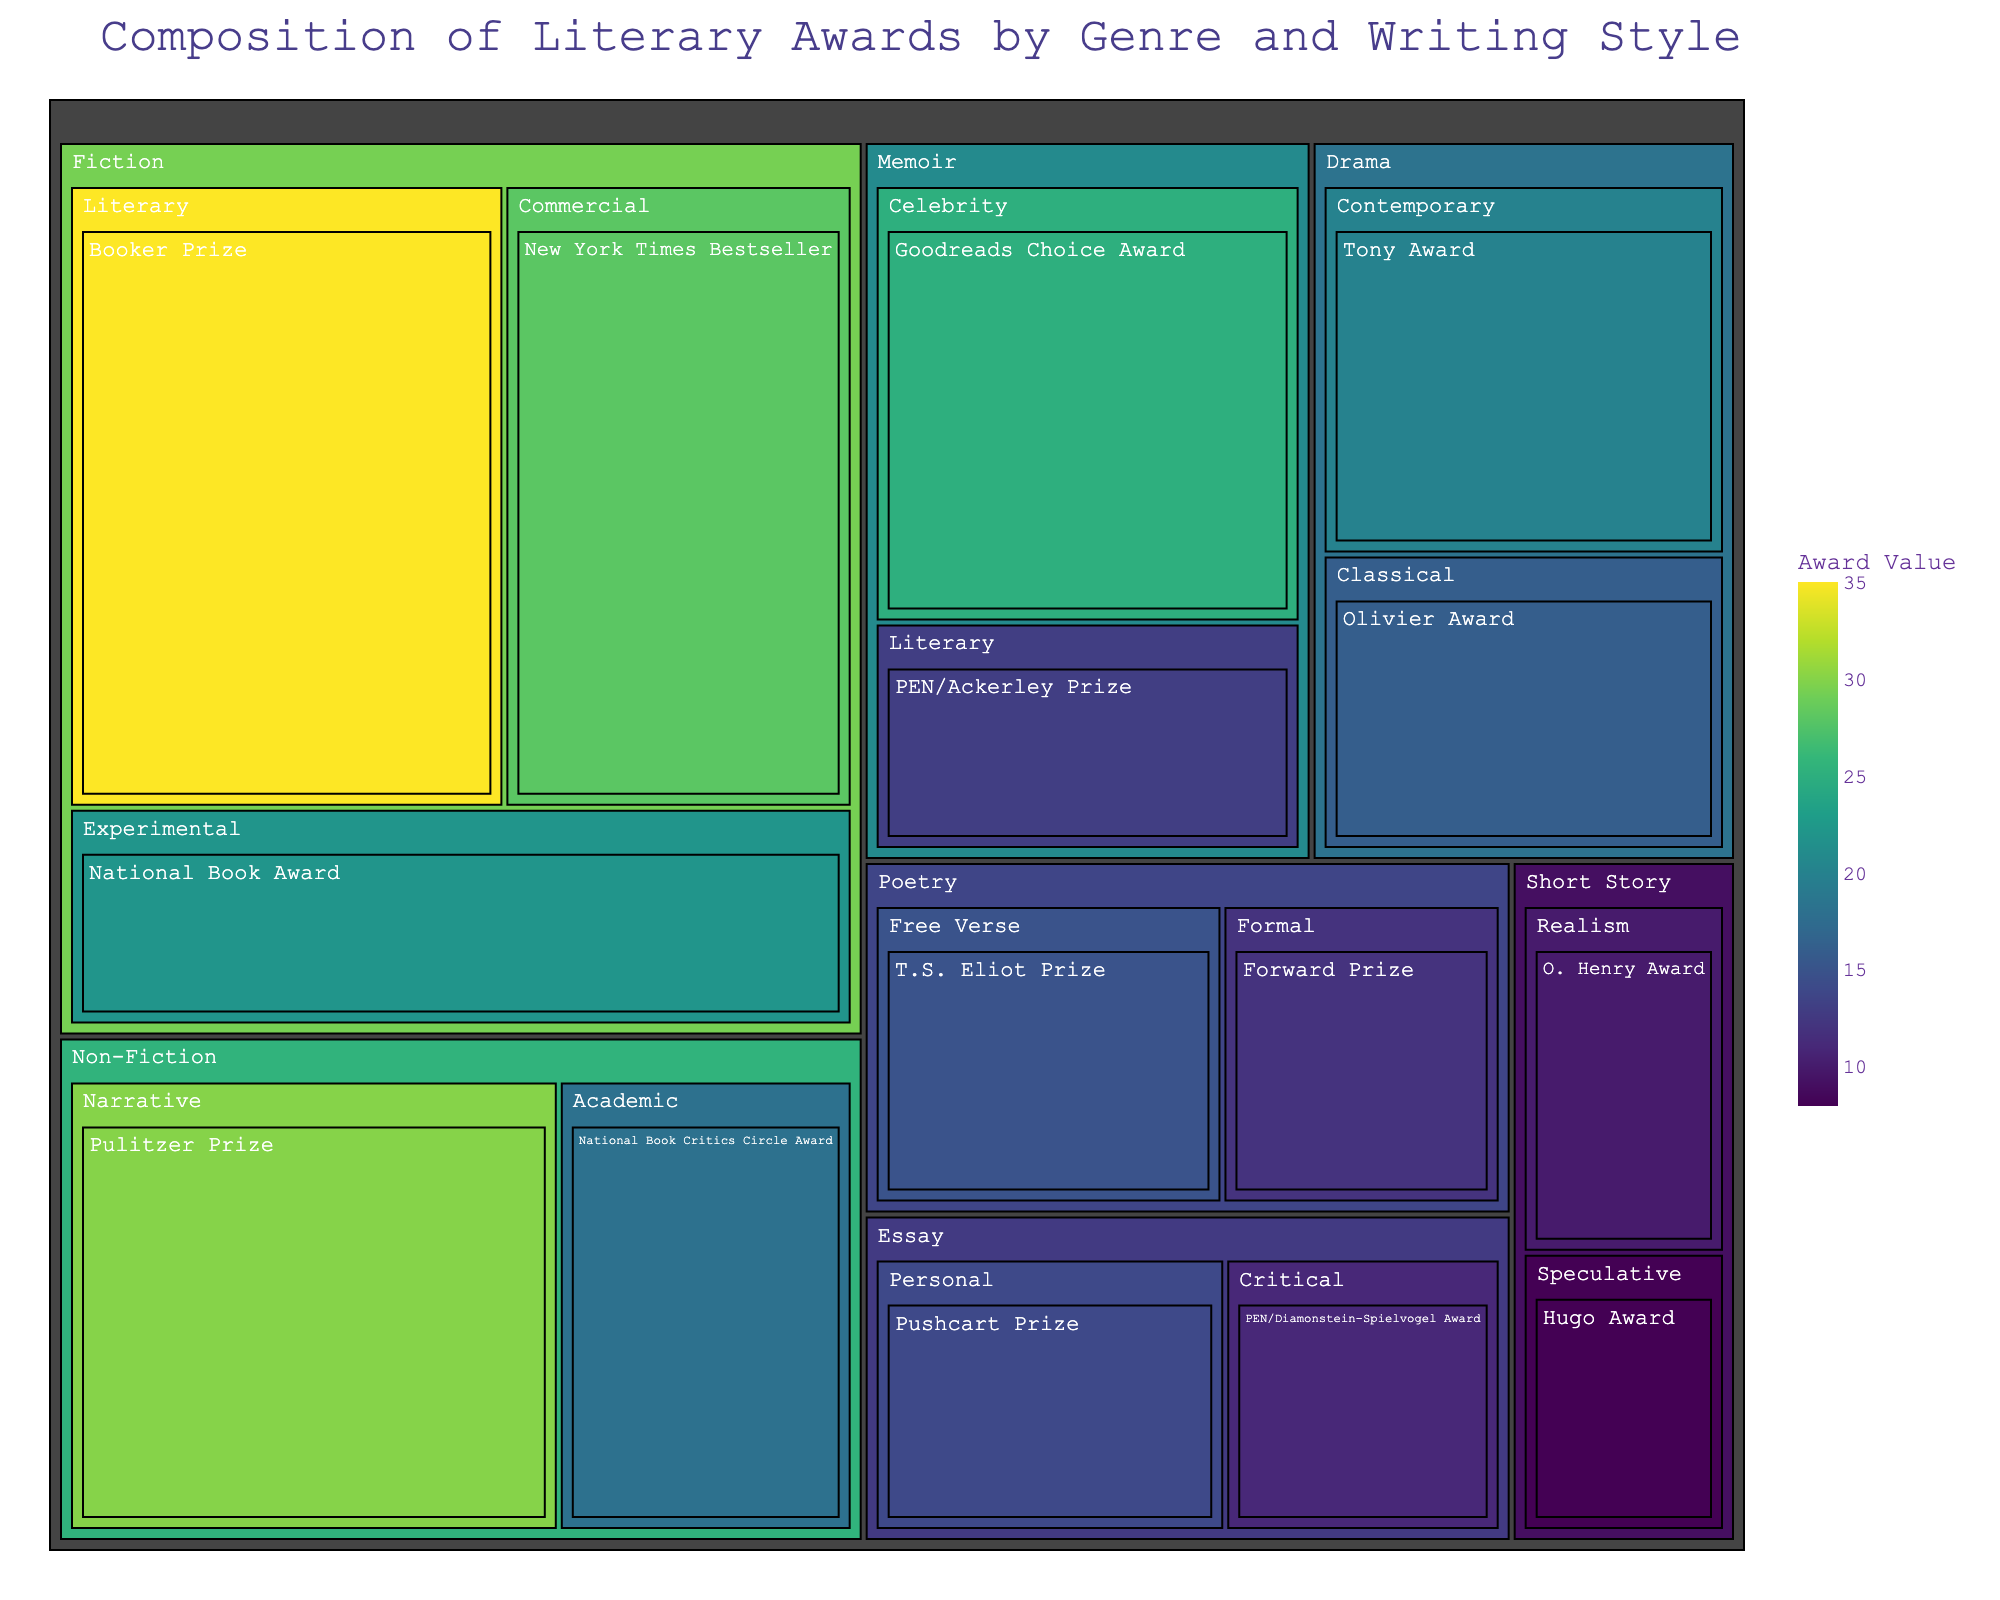What is the title of the treemap? The title is typically prominently displayed at the top of the treemap.
Answer: Composition of Literary Awards by Genre and Writing Style Which genre has the highest total award value? The genre with the largest area will have the highest total award value. Fiction has the largest area in the treemap.
Answer: Fiction In the Fiction genre, which writing style has the highest award value? Within the Fiction genre, look for the segment with the largest area or darkest color. Literary has the largest area and the highest value.
Answer: Literary What is the total award value for Poetry? Sum the values for both styles within the Poetry genre: Free Verse and Formal. 15 (Free Verse) + 12 (Formal) = 27
Answer: 27 Which award has the highest value within the Non-Fiction genre? Within the Non-Fiction genre, the award with the largest area or darkest color represents the highest value. The Pulitzer Prize has the highest value.
Answer: Pulitzer Prize How does the total award value for Memoir compare to Non-Fiction? Sum the award values for all writing styles within each genre and compare. Memoir: 25 (Celebrity) + 13 (Literary) = 38, Non-Fiction: 30 (Narrative) + 18 (Academic) = 48, therefore Non-Fiction has a higher total value.
Answer: Non-Fiction What is the total number of awards represented in the treemap? Count the total number of segments each representing an award in the treemap. There are 14 awards.
Answer: 14 Which writing style is represented in both Fiction and another genre? Look for writing styles that appear in multiple genres. Literary style appears in both Fiction and Memoir genres.
Answer: Literary What is the sum of the award values for all types of Drama? Sum the values for the Contemporary and Classical styles within the Drama genre. 20 (Contemporary) + 16 (Classical) = 36
Answer: 36 Which genre has the least number of awards represented? The genre with the least number of segments will have the least number of awards. Both Short Story and Essay have 2 awards each, which is the least.
Answer: Short Story and Essay 